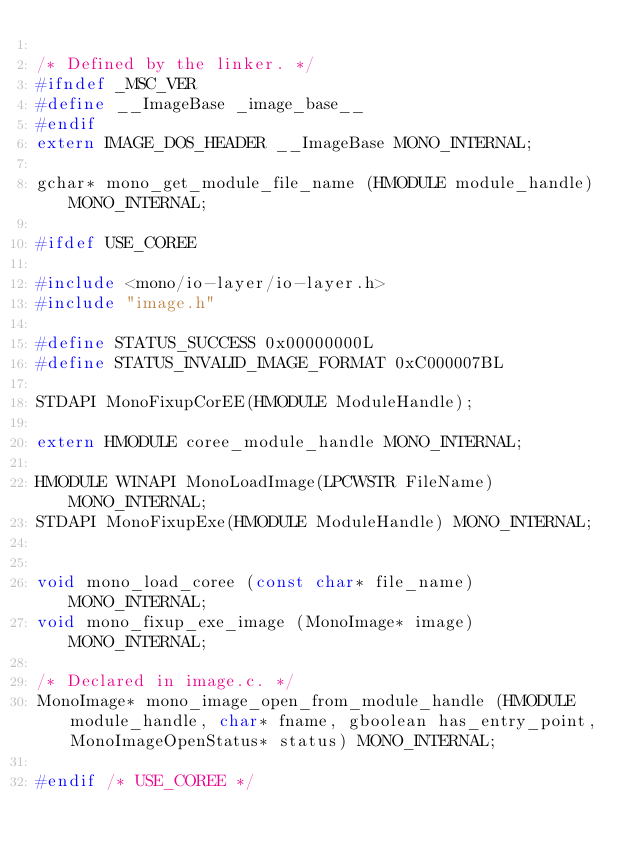<code> <loc_0><loc_0><loc_500><loc_500><_C_>
/* Defined by the linker. */
#ifndef _MSC_VER
#define __ImageBase _image_base__
#endif
extern IMAGE_DOS_HEADER __ImageBase MONO_INTERNAL;

gchar* mono_get_module_file_name (HMODULE module_handle) MONO_INTERNAL;

#ifdef USE_COREE

#include <mono/io-layer/io-layer.h>
#include "image.h"

#define STATUS_SUCCESS 0x00000000L
#define STATUS_INVALID_IMAGE_FORMAT 0xC000007BL

STDAPI MonoFixupCorEE(HMODULE ModuleHandle);

extern HMODULE coree_module_handle MONO_INTERNAL;

HMODULE WINAPI MonoLoadImage(LPCWSTR FileName) MONO_INTERNAL;
STDAPI MonoFixupExe(HMODULE ModuleHandle) MONO_INTERNAL;


void mono_load_coree (const char* file_name) MONO_INTERNAL;
void mono_fixup_exe_image (MonoImage* image) MONO_INTERNAL;

/* Declared in image.c. */
MonoImage* mono_image_open_from_module_handle (HMODULE module_handle, char* fname, gboolean has_entry_point, MonoImageOpenStatus* status) MONO_INTERNAL;

#endif /* USE_COREE */
</code> 